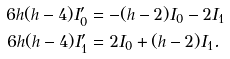Convert formula to latex. <formula><loc_0><loc_0><loc_500><loc_500>6 h ( h - 4 ) I _ { 0 } ^ { \prime } & = - ( h - 2 ) I _ { 0 } - 2 I _ { 1 } \\ 6 h ( h - 4 ) I _ { 1 } ^ { \prime } & = 2 I _ { 0 } + ( h - 2 ) I _ { 1 } . \\</formula> 